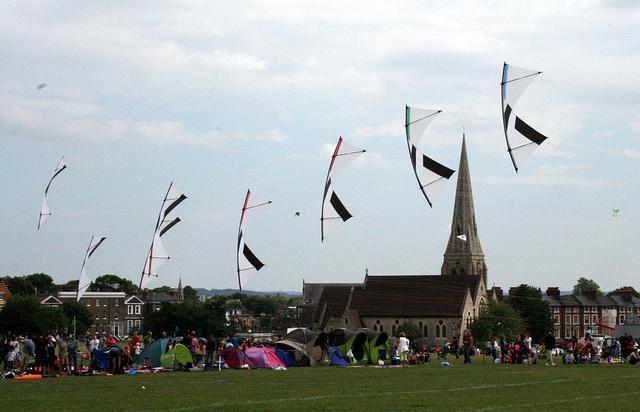How many birds are in the picture?
Give a very brief answer. 0. How many kites are in the photo?
Give a very brief answer. 2. How many red vases are in the picture?
Give a very brief answer. 0. 